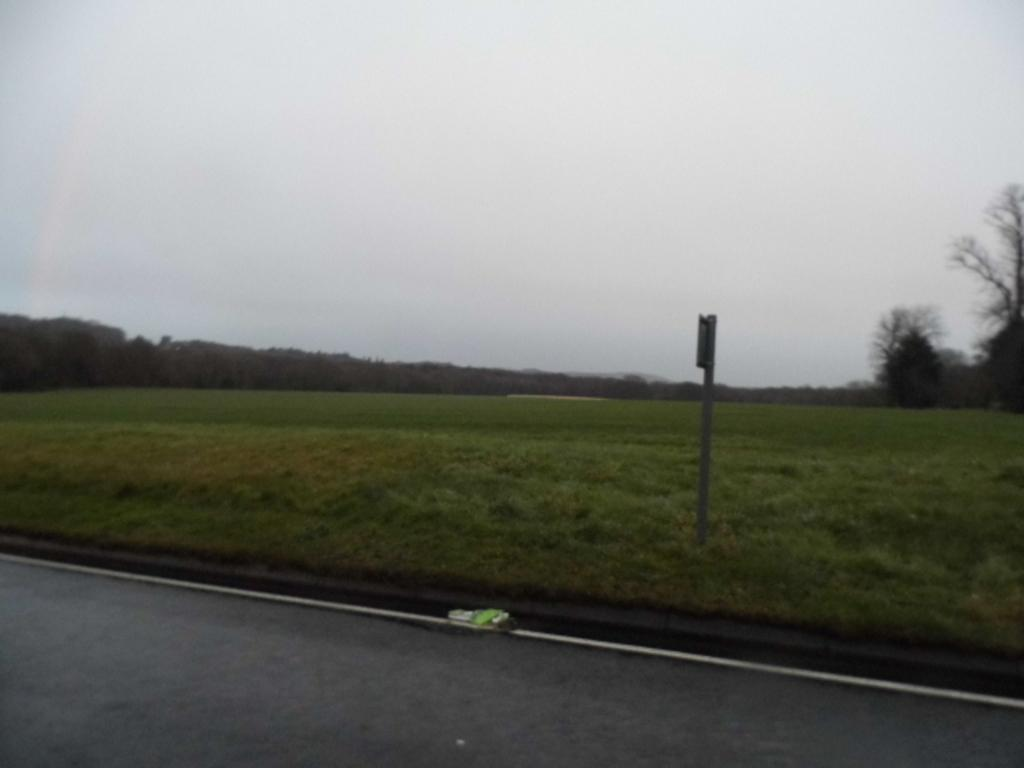What type of vegetation can be seen in the image? There is grass in the image. What structure is present in the image? There is a pole in the image. What type of transportation is visible in the image? There is a vehicle on the road in the image. What other natural elements can be seen in the image? There are trees in the image. What part of the natural environment is visible in the image? The sky is visible in the image. Based on the presence of grass and trees, where might the image have been taken? The image may have been taken near a farm, as grass and trees are commonly found in farm settings. What government operation is being conducted in the image? There is no indication of a government operation in the image. How long did it take for the trees to grow in the image? The growth of trees is not a matter of minutes in the image. 